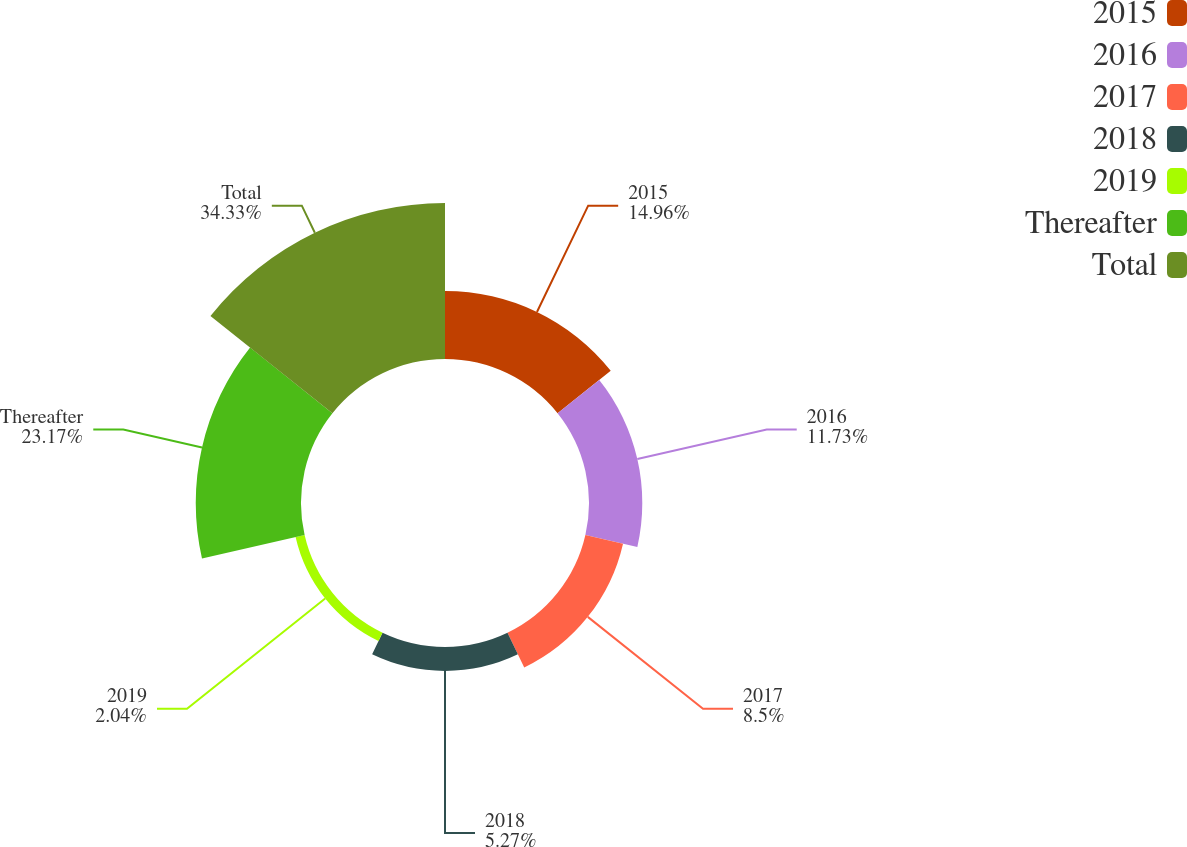<chart> <loc_0><loc_0><loc_500><loc_500><pie_chart><fcel>2015<fcel>2016<fcel>2017<fcel>2018<fcel>2019<fcel>Thereafter<fcel>Total<nl><fcel>14.96%<fcel>11.73%<fcel>8.5%<fcel>5.27%<fcel>2.04%<fcel>23.17%<fcel>34.34%<nl></chart> 